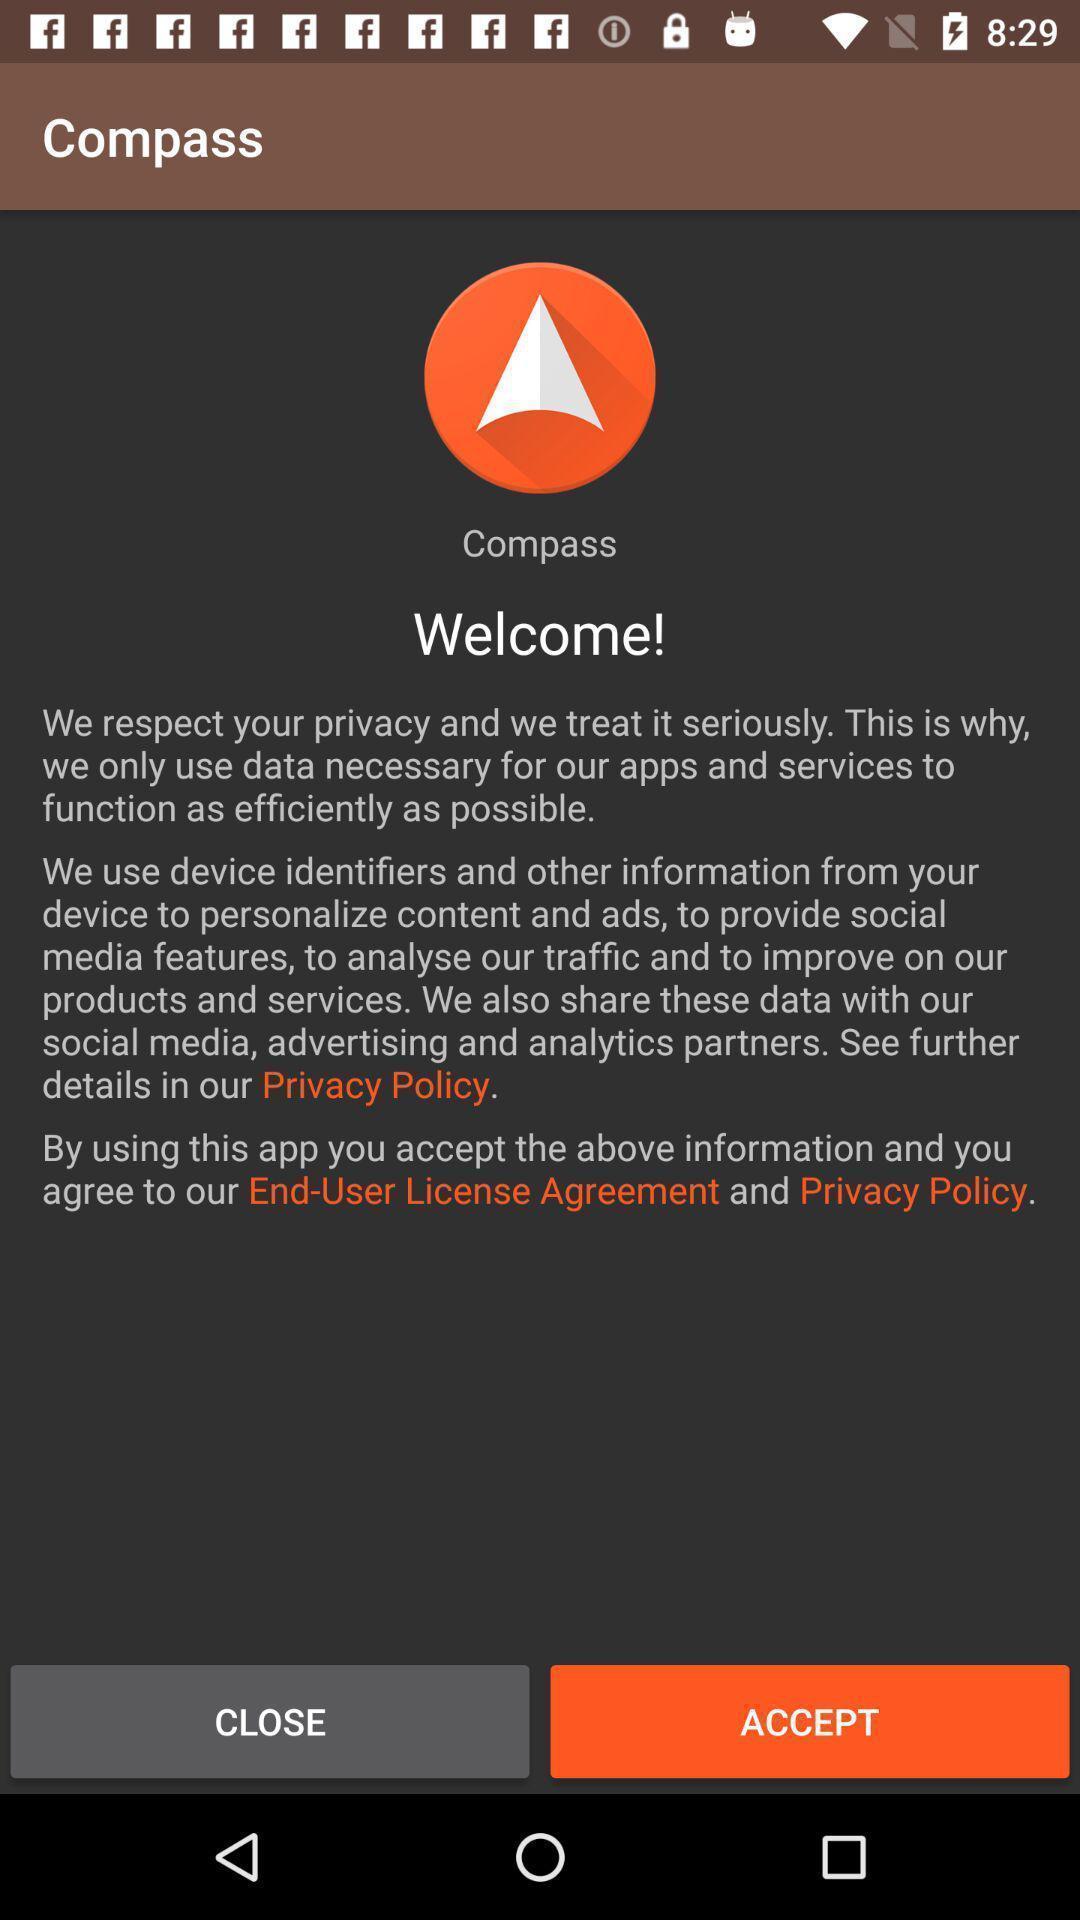What can you discern from this picture? Welcome page of compass with accept and close options. 